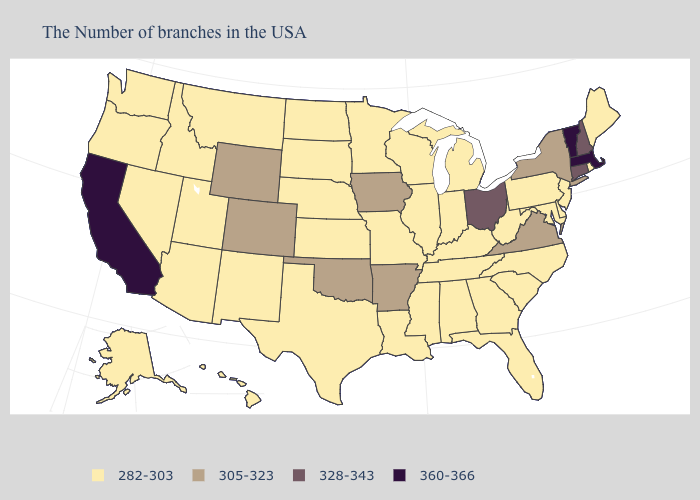What is the lowest value in the USA?
Be succinct. 282-303. Name the states that have a value in the range 282-303?
Answer briefly. Maine, Rhode Island, New Jersey, Delaware, Maryland, Pennsylvania, North Carolina, South Carolina, West Virginia, Florida, Georgia, Michigan, Kentucky, Indiana, Alabama, Tennessee, Wisconsin, Illinois, Mississippi, Louisiana, Missouri, Minnesota, Kansas, Nebraska, Texas, South Dakota, North Dakota, New Mexico, Utah, Montana, Arizona, Idaho, Nevada, Washington, Oregon, Alaska, Hawaii. Does Vermont have the highest value in the USA?
Keep it brief. Yes. What is the value of New Hampshire?
Keep it brief. 328-343. Does the first symbol in the legend represent the smallest category?
Write a very short answer. Yes. Does Oklahoma have the lowest value in the South?
Be succinct. No. Among the states that border Michigan , which have the highest value?
Answer briefly. Ohio. Name the states that have a value in the range 360-366?
Be succinct. Massachusetts, Vermont, California. What is the value of South Carolina?
Concise answer only. 282-303. What is the value of New York?
Answer briefly. 305-323. Among the states that border New York , which have the lowest value?
Write a very short answer. New Jersey, Pennsylvania. Name the states that have a value in the range 328-343?
Quick response, please. New Hampshire, Connecticut, Ohio. What is the value of Alaska?
Quick response, please. 282-303. Is the legend a continuous bar?
Quick response, please. No. How many symbols are there in the legend?
Keep it brief. 4. 